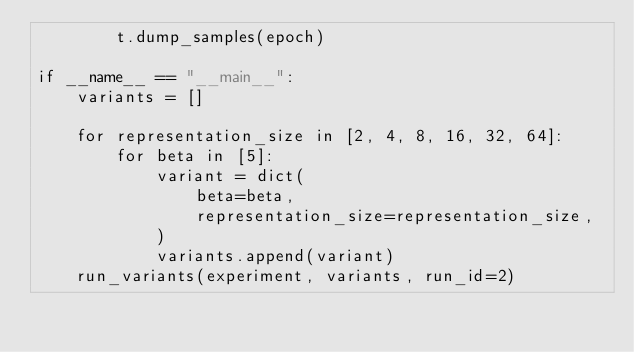<code> <loc_0><loc_0><loc_500><loc_500><_Python_>        t.dump_samples(epoch)

if __name__ == "__main__":
    variants = []

    for representation_size in [2, 4, 8, 16, 32, 64]:
        for beta in [5]:
            variant = dict(
                beta=beta,
                representation_size=representation_size,
            )
            variants.append(variant)
    run_variants(experiment, variants, run_id=2)
</code> 